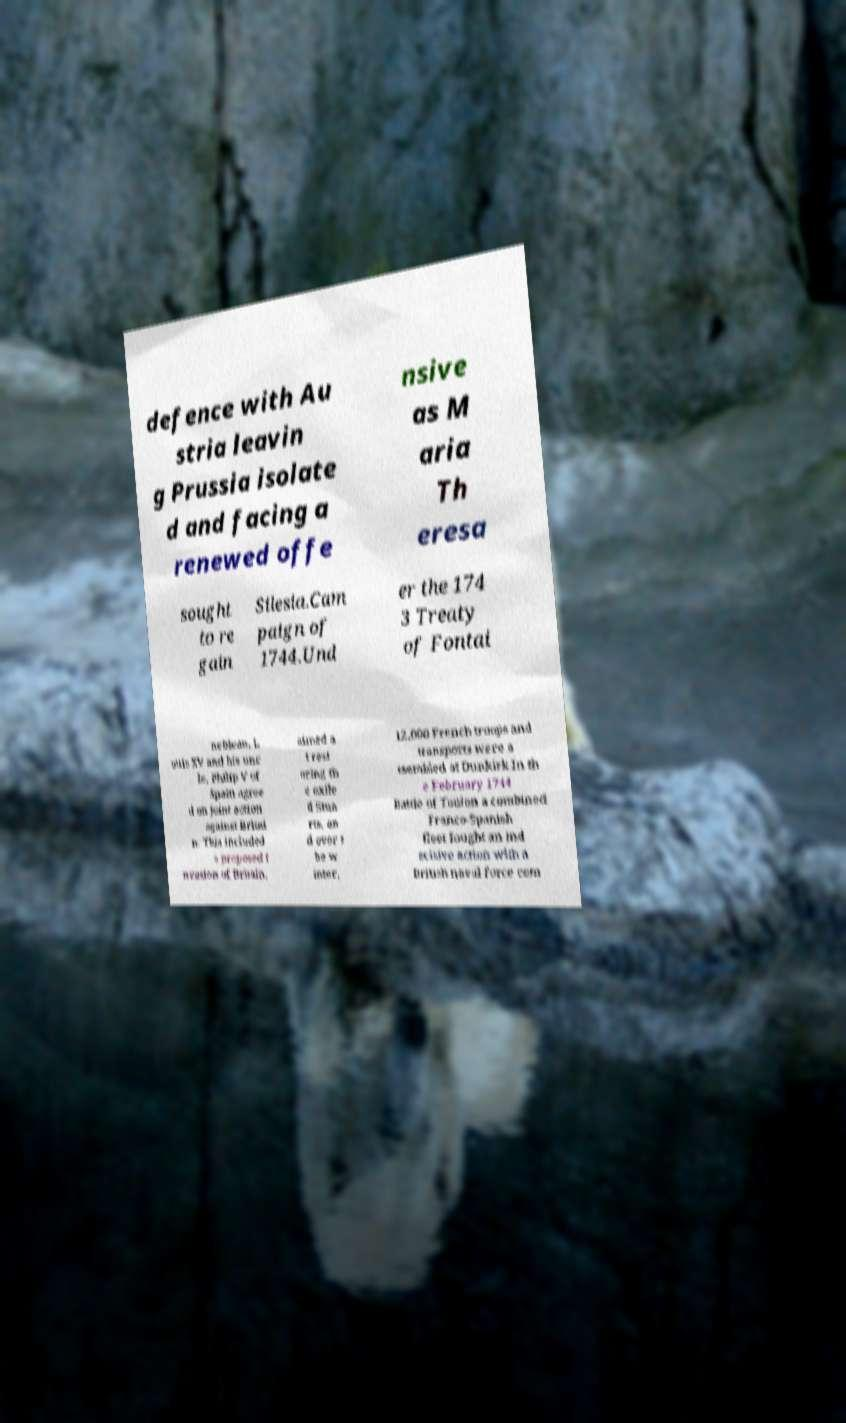Could you assist in decoding the text presented in this image and type it out clearly? defence with Au stria leavin g Prussia isolate d and facing a renewed offe nsive as M aria Th eresa sought to re gain Silesia.Cam paign of 1744.Und er the 174 3 Treaty of Fontai nebleau, L ouis XV and his unc le, Philip V of Spain agree d on joint action against Britai n. This included a proposed i nvasion of Britain, aimed a t rest oring th e exile d Stua rts, an d over t he w inter, 12,000 French troops and transports were a ssembled at Dunkirk.In th e February 1744 Battle of Toulon a combined Franco-Spanish fleet fought an ind ecisive action with a British naval force com 